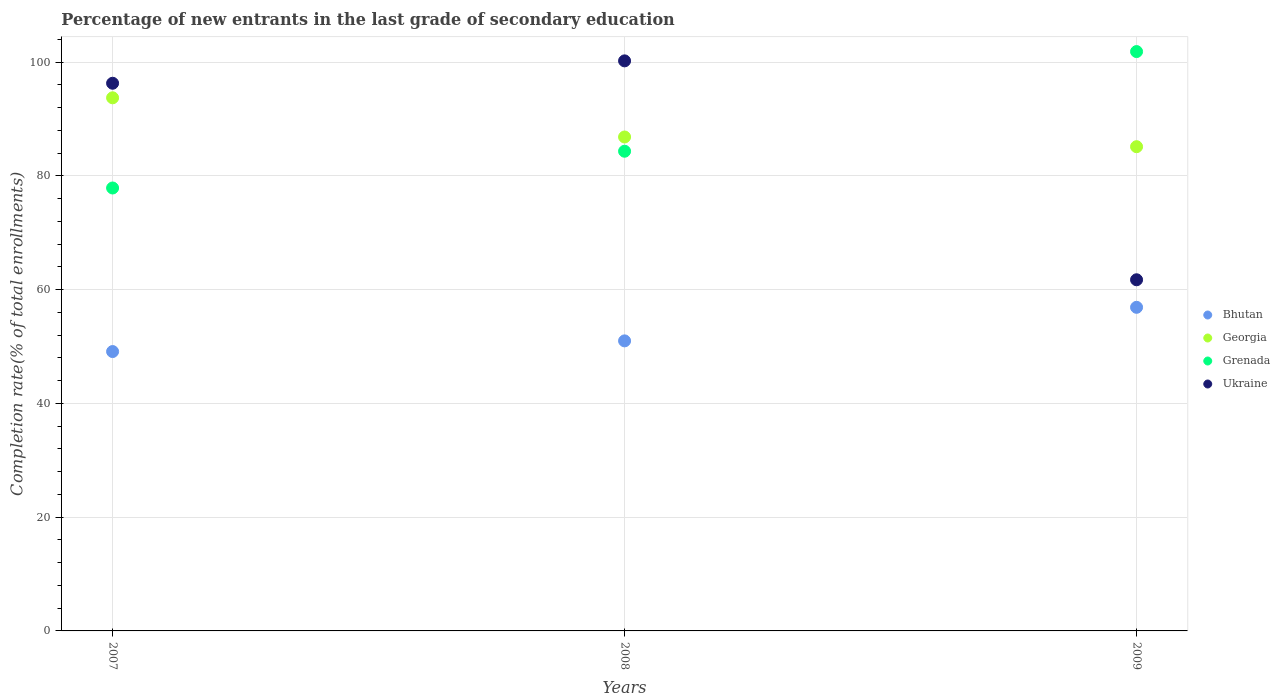How many different coloured dotlines are there?
Your response must be concise. 4. Is the number of dotlines equal to the number of legend labels?
Your answer should be compact. Yes. What is the percentage of new entrants in Ukraine in 2007?
Offer a terse response. 96.28. Across all years, what is the maximum percentage of new entrants in Ukraine?
Ensure brevity in your answer.  100.21. Across all years, what is the minimum percentage of new entrants in Grenada?
Keep it short and to the point. 77.86. What is the total percentage of new entrants in Ukraine in the graph?
Your answer should be very brief. 258.22. What is the difference between the percentage of new entrants in Bhutan in 2007 and that in 2008?
Ensure brevity in your answer.  -1.88. What is the difference between the percentage of new entrants in Georgia in 2009 and the percentage of new entrants in Grenada in 2008?
Ensure brevity in your answer.  0.8. What is the average percentage of new entrants in Georgia per year?
Your answer should be very brief. 88.56. In the year 2007, what is the difference between the percentage of new entrants in Bhutan and percentage of new entrants in Ukraine?
Give a very brief answer. -47.17. What is the ratio of the percentage of new entrants in Grenada in 2007 to that in 2008?
Your answer should be very brief. 0.92. Is the percentage of new entrants in Ukraine in 2007 less than that in 2008?
Your response must be concise. Yes. Is the difference between the percentage of new entrants in Bhutan in 2008 and 2009 greater than the difference between the percentage of new entrants in Ukraine in 2008 and 2009?
Offer a very short reply. No. What is the difference between the highest and the second highest percentage of new entrants in Grenada?
Keep it short and to the point. 17.52. What is the difference between the highest and the lowest percentage of new entrants in Grenada?
Make the answer very short. 23.98. In how many years, is the percentage of new entrants in Georgia greater than the average percentage of new entrants in Georgia taken over all years?
Give a very brief answer. 1. Is the sum of the percentage of new entrants in Georgia in 2007 and 2009 greater than the maximum percentage of new entrants in Grenada across all years?
Ensure brevity in your answer.  Yes. Is it the case that in every year, the sum of the percentage of new entrants in Georgia and percentage of new entrants in Bhutan  is greater than the percentage of new entrants in Grenada?
Provide a short and direct response. Yes. Is the percentage of new entrants in Ukraine strictly greater than the percentage of new entrants in Georgia over the years?
Your answer should be very brief. No. How many dotlines are there?
Provide a succinct answer. 4. Where does the legend appear in the graph?
Your answer should be very brief. Center right. What is the title of the graph?
Offer a very short reply. Percentage of new entrants in the last grade of secondary education. What is the label or title of the X-axis?
Provide a succinct answer. Years. What is the label or title of the Y-axis?
Keep it short and to the point. Completion rate(% of total enrollments). What is the Completion rate(% of total enrollments) of Bhutan in 2007?
Your answer should be very brief. 49.11. What is the Completion rate(% of total enrollments) in Georgia in 2007?
Your answer should be compact. 93.72. What is the Completion rate(% of total enrollments) in Grenada in 2007?
Your answer should be compact. 77.86. What is the Completion rate(% of total enrollments) of Ukraine in 2007?
Give a very brief answer. 96.28. What is the Completion rate(% of total enrollments) of Bhutan in 2008?
Make the answer very short. 50.99. What is the Completion rate(% of total enrollments) in Georgia in 2008?
Provide a succinct answer. 86.83. What is the Completion rate(% of total enrollments) of Grenada in 2008?
Your answer should be compact. 84.33. What is the Completion rate(% of total enrollments) in Ukraine in 2008?
Your answer should be compact. 100.21. What is the Completion rate(% of total enrollments) of Bhutan in 2009?
Make the answer very short. 56.89. What is the Completion rate(% of total enrollments) in Georgia in 2009?
Provide a succinct answer. 85.12. What is the Completion rate(% of total enrollments) in Grenada in 2009?
Ensure brevity in your answer.  101.84. What is the Completion rate(% of total enrollments) in Ukraine in 2009?
Make the answer very short. 61.73. Across all years, what is the maximum Completion rate(% of total enrollments) in Bhutan?
Provide a short and direct response. 56.89. Across all years, what is the maximum Completion rate(% of total enrollments) of Georgia?
Keep it short and to the point. 93.72. Across all years, what is the maximum Completion rate(% of total enrollments) of Grenada?
Offer a terse response. 101.84. Across all years, what is the maximum Completion rate(% of total enrollments) of Ukraine?
Give a very brief answer. 100.21. Across all years, what is the minimum Completion rate(% of total enrollments) in Bhutan?
Your answer should be compact. 49.11. Across all years, what is the minimum Completion rate(% of total enrollments) in Georgia?
Provide a short and direct response. 85.12. Across all years, what is the minimum Completion rate(% of total enrollments) in Grenada?
Offer a terse response. 77.86. Across all years, what is the minimum Completion rate(% of total enrollments) of Ukraine?
Provide a short and direct response. 61.73. What is the total Completion rate(% of total enrollments) in Bhutan in the graph?
Your answer should be very brief. 156.99. What is the total Completion rate(% of total enrollments) in Georgia in the graph?
Keep it short and to the point. 265.67. What is the total Completion rate(% of total enrollments) of Grenada in the graph?
Keep it short and to the point. 264.03. What is the total Completion rate(% of total enrollments) in Ukraine in the graph?
Make the answer very short. 258.22. What is the difference between the Completion rate(% of total enrollments) of Bhutan in 2007 and that in 2008?
Give a very brief answer. -1.88. What is the difference between the Completion rate(% of total enrollments) of Georgia in 2007 and that in 2008?
Your answer should be compact. 6.89. What is the difference between the Completion rate(% of total enrollments) in Grenada in 2007 and that in 2008?
Make the answer very short. -6.46. What is the difference between the Completion rate(% of total enrollments) in Ukraine in 2007 and that in 2008?
Offer a terse response. -3.94. What is the difference between the Completion rate(% of total enrollments) in Bhutan in 2007 and that in 2009?
Offer a terse response. -7.78. What is the difference between the Completion rate(% of total enrollments) of Georgia in 2007 and that in 2009?
Your response must be concise. 8.59. What is the difference between the Completion rate(% of total enrollments) in Grenada in 2007 and that in 2009?
Your answer should be very brief. -23.98. What is the difference between the Completion rate(% of total enrollments) of Ukraine in 2007 and that in 2009?
Your answer should be very brief. 34.55. What is the difference between the Completion rate(% of total enrollments) in Bhutan in 2008 and that in 2009?
Your answer should be compact. -5.9. What is the difference between the Completion rate(% of total enrollments) in Georgia in 2008 and that in 2009?
Provide a succinct answer. 1.71. What is the difference between the Completion rate(% of total enrollments) of Grenada in 2008 and that in 2009?
Give a very brief answer. -17.52. What is the difference between the Completion rate(% of total enrollments) of Ukraine in 2008 and that in 2009?
Provide a short and direct response. 38.48. What is the difference between the Completion rate(% of total enrollments) of Bhutan in 2007 and the Completion rate(% of total enrollments) of Georgia in 2008?
Provide a succinct answer. -37.72. What is the difference between the Completion rate(% of total enrollments) of Bhutan in 2007 and the Completion rate(% of total enrollments) of Grenada in 2008?
Offer a terse response. -35.22. What is the difference between the Completion rate(% of total enrollments) in Bhutan in 2007 and the Completion rate(% of total enrollments) in Ukraine in 2008?
Your answer should be very brief. -51.1. What is the difference between the Completion rate(% of total enrollments) of Georgia in 2007 and the Completion rate(% of total enrollments) of Grenada in 2008?
Your answer should be very brief. 9.39. What is the difference between the Completion rate(% of total enrollments) of Georgia in 2007 and the Completion rate(% of total enrollments) of Ukraine in 2008?
Provide a short and direct response. -6.49. What is the difference between the Completion rate(% of total enrollments) of Grenada in 2007 and the Completion rate(% of total enrollments) of Ukraine in 2008?
Your answer should be very brief. -22.35. What is the difference between the Completion rate(% of total enrollments) of Bhutan in 2007 and the Completion rate(% of total enrollments) of Georgia in 2009?
Ensure brevity in your answer.  -36.01. What is the difference between the Completion rate(% of total enrollments) in Bhutan in 2007 and the Completion rate(% of total enrollments) in Grenada in 2009?
Make the answer very short. -52.73. What is the difference between the Completion rate(% of total enrollments) in Bhutan in 2007 and the Completion rate(% of total enrollments) in Ukraine in 2009?
Give a very brief answer. -12.62. What is the difference between the Completion rate(% of total enrollments) in Georgia in 2007 and the Completion rate(% of total enrollments) in Grenada in 2009?
Provide a short and direct response. -8.13. What is the difference between the Completion rate(% of total enrollments) in Georgia in 2007 and the Completion rate(% of total enrollments) in Ukraine in 2009?
Your answer should be very brief. 31.99. What is the difference between the Completion rate(% of total enrollments) of Grenada in 2007 and the Completion rate(% of total enrollments) of Ukraine in 2009?
Ensure brevity in your answer.  16.13. What is the difference between the Completion rate(% of total enrollments) in Bhutan in 2008 and the Completion rate(% of total enrollments) in Georgia in 2009?
Provide a short and direct response. -34.14. What is the difference between the Completion rate(% of total enrollments) of Bhutan in 2008 and the Completion rate(% of total enrollments) of Grenada in 2009?
Keep it short and to the point. -50.86. What is the difference between the Completion rate(% of total enrollments) of Bhutan in 2008 and the Completion rate(% of total enrollments) of Ukraine in 2009?
Offer a very short reply. -10.74. What is the difference between the Completion rate(% of total enrollments) of Georgia in 2008 and the Completion rate(% of total enrollments) of Grenada in 2009?
Give a very brief answer. -15.01. What is the difference between the Completion rate(% of total enrollments) of Georgia in 2008 and the Completion rate(% of total enrollments) of Ukraine in 2009?
Your answer should be compact. 25.1. What is the difference between the Completion rate(% of total enrollments) of Grenada in 2008 and the Completion rate(% of total enrollments) of Ukraine in 2009?
Ensure brevity in your answer.  22.6. What is the average Completion rate(% of total enrollments) in Bhutan per year?
Offer a terse response. 52.33. What is the average Completion rate(% of total enrollments) of Georgia per year?
Provide a succinct answer. 88.56. What is the average Completion rate(% of total enrollments) in Grenada per year?
Give a very brief answer. 88.01. What is the average Completion rate(% of total enrollments) of Ukraine per year?
Your answer should be very brief. 86.07. In the year 2007, what is the difference between the Completion rate(% of total enrollments) in Bhutan and Completion rate(% of total enrollments) in Georgia?
Your answer should be compact. -44.61. In the year 2007, what is the difference between the Completion rate(% of total enrollments) of Bhutan and Completion rate(% of total enrollments) of Grenada?
Keep it short and to the point. -28.75. In the year 2007, what is the difference between the Completion rate(% of total enrollments) of Bhutan and Completion rate(% of total enrollments) of Ukraine?
Keep it short and to the point. -47.17. In the year 2007, what is the difference between the Completion rate(% of total enrollments) of Georgia and Completion rate(% of total enrollments) of Grenada?
Provide a short and direct response. 15.85. In the year 2007, what is the difference between the Completion rate(% of total enrollments) of Georgia and Completion rate(% of total enrollments) of Ukraine?
Your answer should be compact. -2.56. In the year 2007, what is the difference between the Completion rate(% of total enrollments) in Grenada and Completion rate(% of total enrollments) in Ukraine?
Your response must be concise. -18.41. In the year 2008, what is the difference between the Completion rate(% of total enrollments) of Bhutan and Completion rate(% of total enrollments) of Georgia?
Offer a very short reply. -35.84. In the year 2008, what is the difference between the Completion rate(% of total enrollments) of Bhutan and Completion rate(% of total enrollments) of Grenada?
Provide a short and direct response. -33.34. In the year 2008, what is the difference between the Completion rate(% of total enrollments) in Bhutan and Completion rate(% of total enrollments) in Ukraine?
Offer a terse response. -49.22. In the year 2008, what is the difference between the Completion rate(% of total enrollments) in Georgia and Completion rate(% of total enrollments) in Grenada?
Offer a very short reply. 2.5. In the year 2008, what is the difference between the Completion rate(% of total enrollments) in Georgia and Completion rate(% of total enrollments) in Ukraine?
Ensure brevity in your answer.  -13.38. In the year 2008, what is the difference between the Completion rate(% of total enrollments) in Grenada and Completion rate(% of total enrollments) in Ukraine?
Ensure brevity in your answer.  -15.88. In the year 2009, what is the difference between the Completion rate(% of total enrollments) in Bhutan and Completion rate(% of total enrollments) in Georgia?
Your response must be concise. -28.24. In the year 2009, what is the difference between the Completion rate(% of total enrollments) in Bhutan and Completion rate(% of total enrollments) in Grenada?
Keep it short and to the point. -44.96. In the year 2009, what is the difference between the Completion rate(% of total enrollments) in Bhutan and Completion rate(% of total enrollments) in Ukraine?
Offer a terse response. -4.84. In the year 2009, what is the difference between the Completion rate(% of total enrollments) of Georgia and Completion rate(% of total enrollments) of Grenada?
Provide a succinct answer. -16.72. In the year 2009, what is the difference between the Completion rate(% of total enrollments) in Georgia and Completion rate(% of total enrollments) in Ukraine?
Keep it short and to the point. 23.39. In the year 2009, what is the difference between the Completion rate(% of total enrollments) in Grenada and Completion rate(% of total enrollments) in Ukraine?
Offer a very short reply. 40.11. What is the ratio of the Completion rate(% of total enrollments) in Bhutan in 2007 to that in 2008?
Keep it short and to the point. 0.96. What is the ratio of the Completion rate(% of total enrollments) of Georgia in 2007 to that in 2008?
Your answer should be compact. 1.08. What is the ratio of the Completion rate(% of total enrollments) of Grenada in 2007 to that in 2008?
Offer a terse response. 0.92. What is the ratio of the Completion rate(% of total enrollments) in Ukraine in 2007 to that in 2008?
Offer a very short reply. 0.96. What is the ratio of the Completion rate(% of total enrollments) in Bhutan in 2007 to that in 2009?
Provide a succinct answer. 0.86. What is the ratio of the Completion rate(% of total enrollments) in Georgia in 2007 to that in 2009?
Ensure brevity in your answer.  1.1. What is the ratio of the Completion rate(% of total enrollments) in Grenada in 2007 to that in 2009?
Your answer should be compact. 0.76. What is the ratio of the Completion rate(% of total enrollments) of Ukraine in 2007 to that in 2009?
Make the answer very short. 1.56. What is the ratio of the Completion rate(% of total enrollments) of Bhutan in 2008 to that in 2009?
Give a very brief answer. 0.9. What is the ratio of the Completion rate(% of total enrollments) of Grenada in 2008 to that in 2009?
Give a very brief answer. 0.83. What is the ratio of the Completion rate(% of total enrollments) in Ukraine in 2008 to that in 2009?
Ensure brevity in your answer.  1.62. What is the difference between the highest and the second highest Completion rate(% of total enrollments) in Bhutan?
Ensure brevity in your answer.  5.9. What is the difference between the highest and the second highest Completion rate(% of total enrollments) of Georgia?
Keep it short and to the point. 6.89. What is the difference between the highest and the second highest Completion rate(% of total enrollments) of Grenada?
Provide a short and direct response. 17.52. What is the difference between the highest and the second highest Completion rate(% of total enrollments) of Ukraine?
Give a very brief answer. 3.94. What is the difference between the highest and the lowest Completion rate(% of total enrollments) of Bhutan?
Keep it short and to the point. 7.78. What is the difference between the highest and the lowest Completion rate(% of total enrollments) of Georgia?
Give a very brief answer. 8.59. What is the difference between the highest and the lowest Completion rate(% of total enrollments) of Grenada?
Make the answer very short. 23.98. What is the difference between the highest and the lowest Completion rate(% of total enrollments) in Ukraine?
Offer a very short reply. 38.48. 